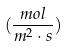Convert formula to latex. <formula><loc_0><loc_0><loc_500><loc_500>( \frac { m o l } { m ^ { 2 } \cdot s } )</formula> 